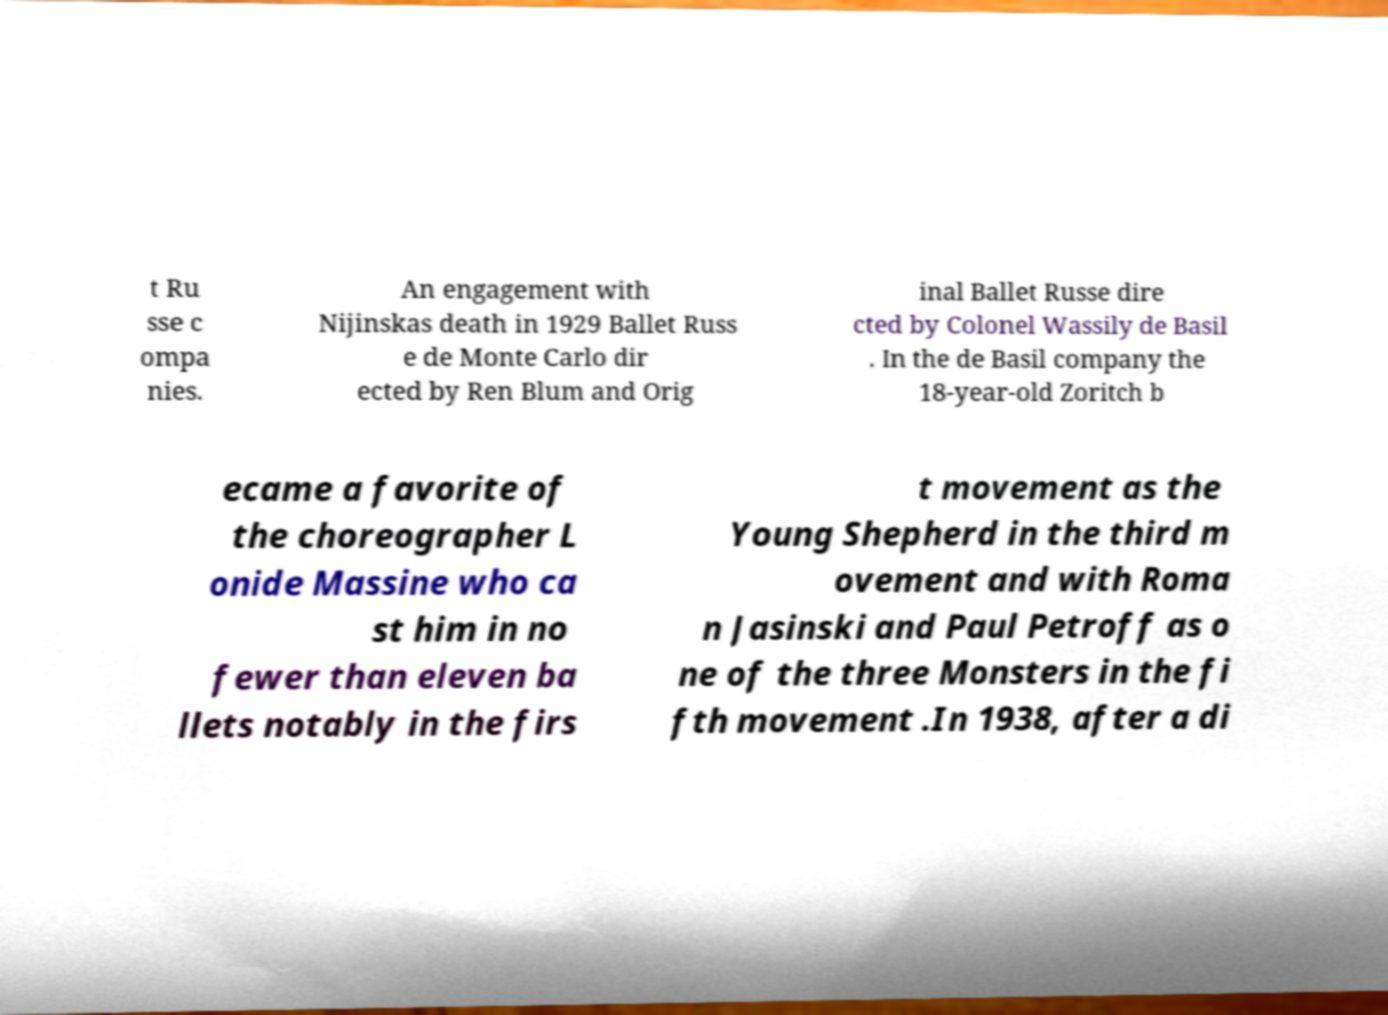Can you read and provide the text displayed in the image?This photo seems to have some interesting text. Can you extract and type it out for me? t Ru sse c ompa nies. An engagement with Nijinskas death in 1929 Ballet Russ e de Monte Carlo dir ected by Ren Blum and Orig inal Ballet Russe dire cted by Colonel Wassily de Basil . In the de Basil company the 18-year-old Zoritch b ecame a favorite of the choreographer L onide Massine who ca st him in no fewer than eleven ba llets notably in the firs t movement as the Young Shepherd in the third m ovement and with Roma n Jasinski and Paul Petroff as o ne of the three Monsters in the fi fth movement .In 1938, after a di 